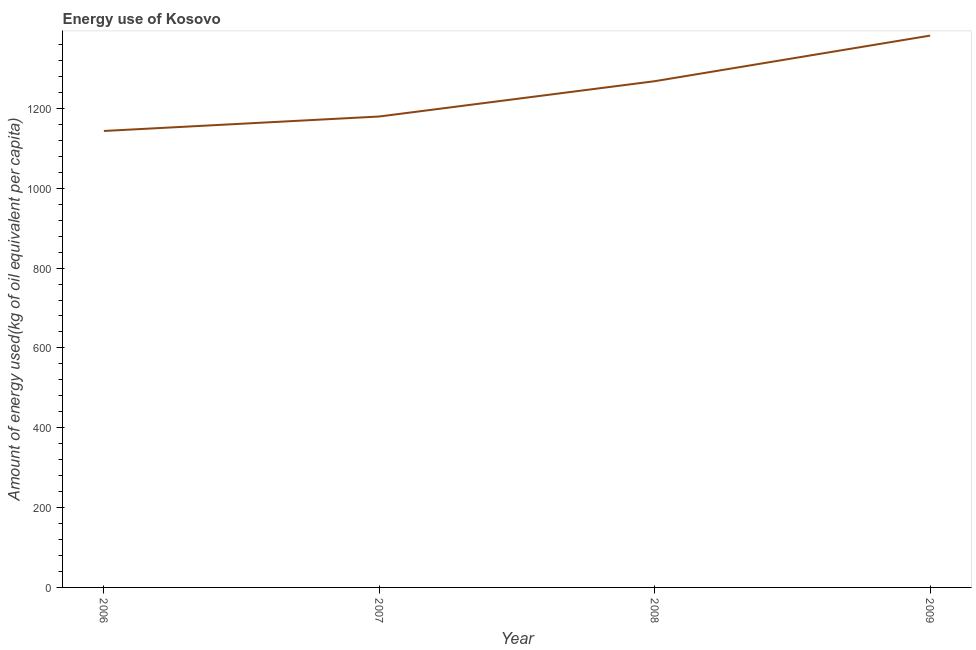What is the amount of energy used in 2009?
Your answer should be compact. 1382.43. Across all years, what is the maximum amount of energy used?
Provide a short and direct response. 1382.43. Across all years, what is the minimum amount of energy used?
Give a very brief answer. 1143.5. In which year was the amount of energy used maximum?
Offer a very short reply. 2009. What is the sum of the amount of energy used?
Provide a succinct answer. 4973.88. What is the difference between the amount of energy used in 2006 and 2009?
Your answer should be very brief. -238.92. What is the average amount of energy used per year?
Give a very brief answer. 1243.47. What is the median amount of energy used?
Ensure brevity in your answer.  1223.98. What is the ratio of the amount of energy used in 2007 to that in 2009?
Offer a very short reply. 0.85. Is the amount of energy used in 2006 less than that in 2008?
Offer a very short reply. Yes. Is the difference between the amount of energy used in 2006 and 2007 greater than the difference between any two years?
Provide a succinct answer. No. What is the difference between the highest and the second highest amount of energy used?
Offer a terse response. 114.23. What is the difference between the highest and the lowest amount of energy used?
Ensure brevity in your answer.  238.92. Does the amount of energy used monotonically increase over the years?
Provide a succinct answer. Yes. How many years are there in the graph?
Provide a short and direct response. 4. Are the values on the major ticks of Y-axis written in scientific E-notation?
Your answer should be very brief. No. Does the graph contain any zero values?
Keep it short and to the point. No. Does the graph contain grids?
Your answer should be very brief. No. What is the title of the graph?
Your answer should be compact. Energy use of Kosovo. What is the label or title of the X-axis?
Provide a short and direct response. Year. What is the label or title of the Y-axis?
Your answer should be compact. Amount of energy used(kg of oil equivalent per capita). What is the Amount of energy used(kg of oil equivalent per capita) in 2006?
Keep it short and to the point. 1143.5. What is the Amount of energy used(kg of oil equivalent per capita) of 2007?
Your answer should be very brief. 1179.76. What is the Amount of energy used(kg of oil equivalent per capita) of 2008?
Your response must be concise. 1268.2. What is the Amount of energy used(kg of oil equivalent per capita) in 2009?
Provide a succinct answer. 1382.43. What is the difference between the Amount of energy used(kg of oil equivalent per capita) in 2006 and 2007?
Ensure brevity in your answer.  -36.26. What is the difference between the Amount of energy used(kg of oil equivalent per capita) in 2006 and 2008?
Your response must be concise. -124.7. What is the difference between the Amount of energy used(kg of oil equivalent per capita) in 2006 and 2009?
Provide a short and direct response. -238.92. What is the difference between the Amount of energy used(kg of oil equivalent per capita) in 2007 and 2008?
Your answer should be compact. -88.44. What is the difference between the Amount of energy used(kg of oil equivalent per capita) in 2007 and 2009?
Keep it short and to the point. -202.67. What is the difference between the Amount of energy used(kg of oil equivalent per capita) in 2008 and 2009?
Your response must be concise. -114.23. What is the ratio of the Amount of energy used(kg of oil equivalent per capita) in 2006 to that in 2007?
Your answer should be compact. 0.97. What is the ratio of the Amount of energy used(kg of oil equivalent per capita) in 2006 to that in 2008?
Offer a very short reply. 0.9. What is the ratio of the Amount of energy used(kg of oil equivalent per capita) in 2006 to that in 2009?
Provide a succinct answer. 0.83. What is the ratio of the Amount of energy used(kg of oil equivalent per capita) in 2007 to that in 2009?
Make the answer very short. 0.85. What is the ratio of the Amount of energy used(kg of oil equivalent per capita) in 2008 to that in 2009?
Your response must be concise. 0.92. 